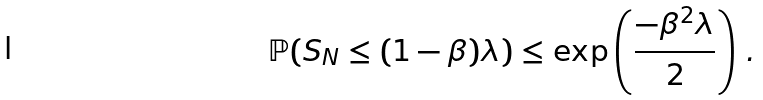Convert formula to latex. <formula><loc_0><loc_0><loc_500><loc_500>\mathbb { P } ( S _ { N } \leq ( 1 - \beta ) \lambda ) \leq \exp \left ( \frac { - \beta ^ { 2 } \lambda } { 2 } \right ) \, .</formula> 